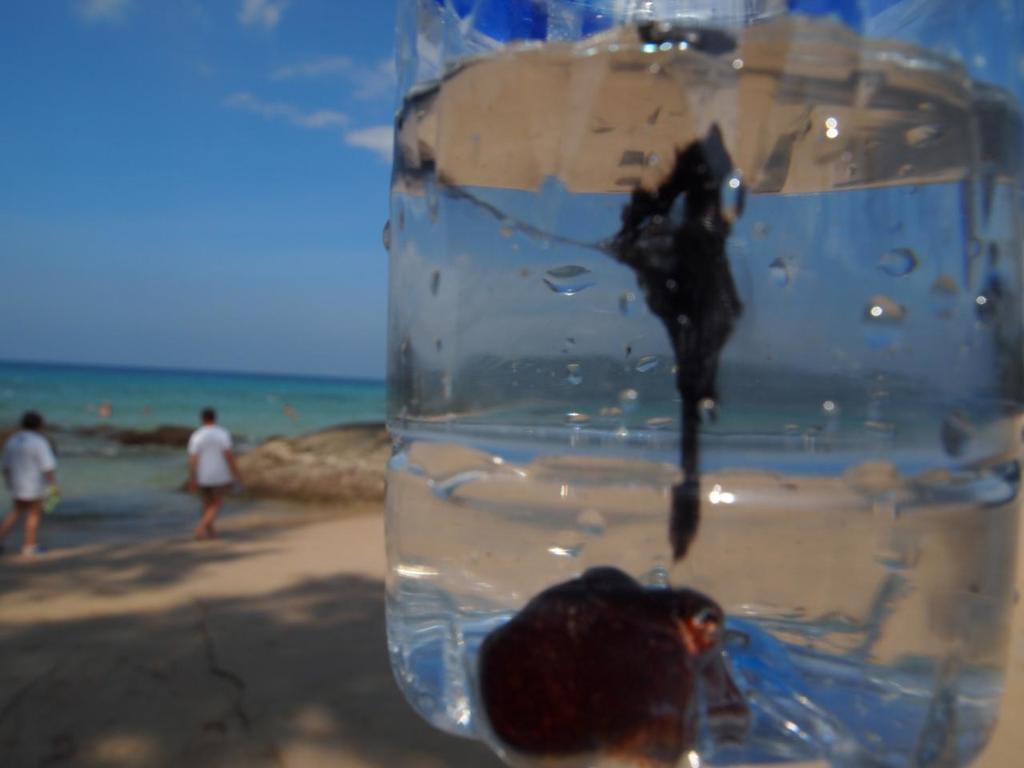What is the primary element in the image? There is water in the image. What can be seen within the water? There are objects in the water. Where are the two persons located in the image? They are standing in the left corner of the image. What is visible in the background of the image? There is water visible in the background of the image. What is the distribution of the show in the image? There is no show mentioned or depicted in the image, so it is not possible to discuss its distribution. 